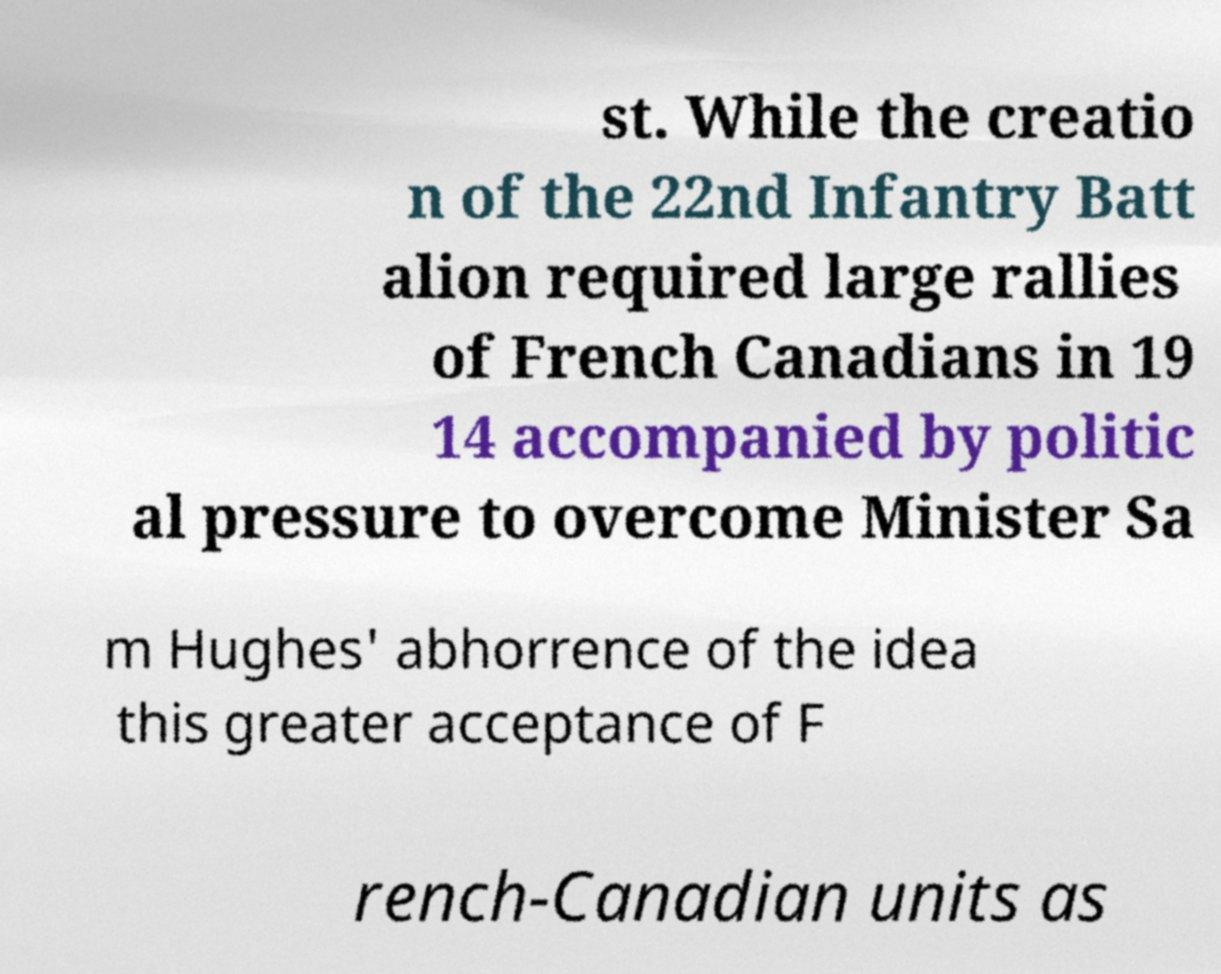Please read and relay the text visible in this image. What does it say? st. While the creatio n of the 22nd Infantry Batt alion required large rallies of French Canadians in 19 14 accompanied by politic al pressure to overcome Minister Sa m Hughes' abhorrence of the idea this greater acceptance of F rench-Canadian units as 